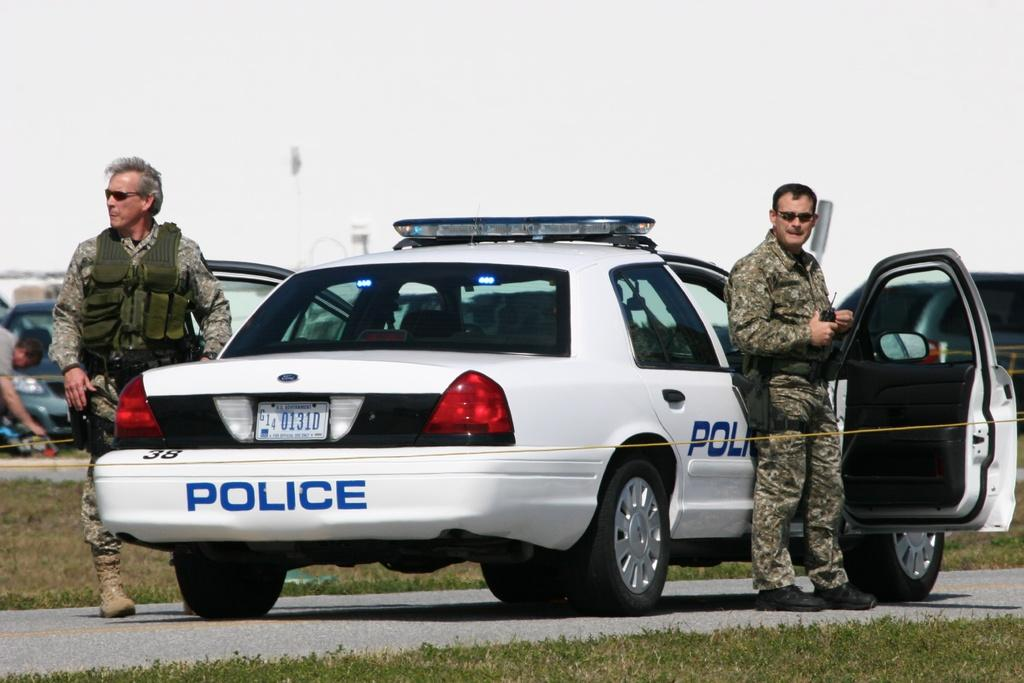What type of vehicles can be seen in the image? There are cars in the image. How many people are present in the image? There are three persons in the image. What type of natural environment is visible in the image? There is grass visible in the image. What is visible in the background of the image? There is sky visible in the background of the image. What type of mountain can be seen in the image? There is no mountain present in the image. What is the fear of the person in the image? The image does not provide any information about the emotions or fears of the persons in the image. 